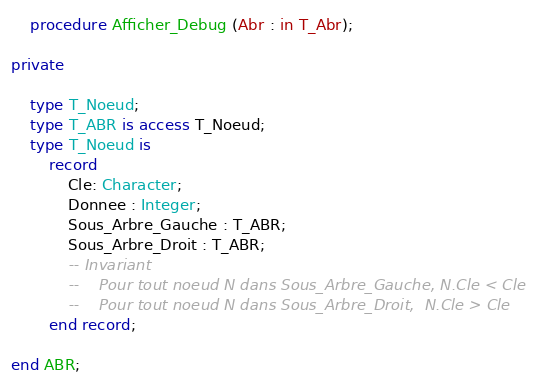Convert code to text. <code><loc_0><loc_0><loc_500><loc_500><_Ada_>	procedure Afficher_Debug (Abr : in T_Abr);

private

	type T_Noeud;
	type T_ABR is access T_Noeud;
	type T_Noeud is
		record
			Cle: Character;
			Donnee : Integer;
			Sous_Arbre_Gauche : T_ABR;
			Sous_Arbre_Droit : T_ABR;
			-- Invariant
			--    Pour tout noeud N dans Sous_Arbre_Gauche, N.Cle < Cle
			--    Pour tout noeud N dans Sous_Arbre_Droit,  N.Cle > Cle
		end record;

end ABR;
</code> 